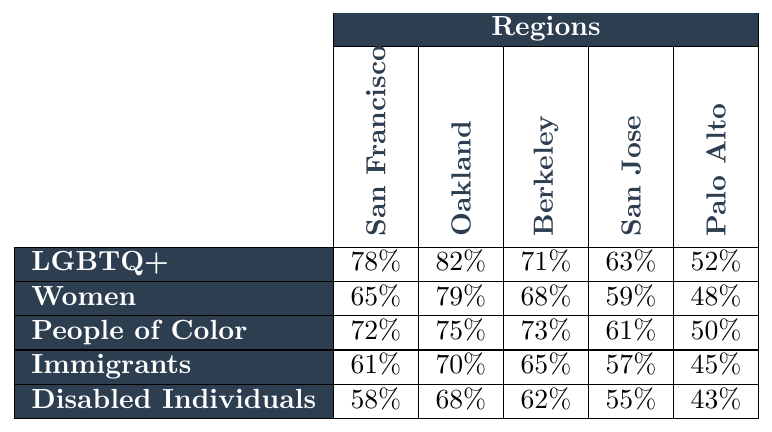What is the attendance rate for women in Oakland? The table shows the attendance rate for women in Oakland is indicated in the intersection of the "Women" row and the "Oakland" column, which is 79%.
Answer: 79% Which community has the lowest attendance rate in Palo Alto? The table shows the attendance rates for each community in Palo Alto. Analyzing the values, Disabled Individuals have the lowest attendance rate at 43%.
Answer: Disabled Individuals What is the average attendance rate for LGBTQ+ individuals across all regions? To find the average, I sum the attendance rates for LGBTQ+ individuals: (78 + 82 + 71 + 63 + 52) = 346. Then, I divide by the number of regions, which is 5, so 346 / 5 = 69.2%.
Answer: 69.2% Is the attendance rate for immigrants in San Jose higher than that for disabled individuals in San Francisco? The attendance rate for immigrants in San Jose is 57%, while the attendance rate for disabled individuals in San Francisco is 58%. Since 57% is less than 58%, the answer is no.
Answer: No Which group shows the highest attendance rate overall? I need to look at all the highest values in each row and then compare them. LGBTQ+ individuals have the highest attendance in Oakland at 82%.
Answer: LGBTQ+ (Oakland) What is the difference in attendance rates between women in San Francisco and women in San Jose? The attendance rate for women in San Francisco is 65% and for women in San Jose is 59%. To find the difference, I subtract: 65 - 59 = 6%.
Answer: 6% What percentage of individuals in Berkeley attended self-defense classes for People of Color? The table shows that the attendance rate for People of Color in Berkeley is 73%.
Answer: 73% Which community has an attendance rate of over 60% in San Jose? In San Jose, looking at the values, the communities with over 60% attendance are LGBTQ+ (63%), People of Color (61%), and Immigrants (57%). However, Immigrants are not over 60%. Thus, LGBTQ+ and People of Color are the valid communities.
Answer: LGBTQ+, People of Color What is the median attendance rate for disabled individuals across all regions? The attendance rates for disabled individuals are: 58%, 68%, 62%, 55%, and 43%. Sorting these gives: 43%, 55%, 58%, 62%, 68%. The median, which is the middle value in this ordered list, is 58%.
Answer: 58% How does the attendance rate for women in San Francisco compare to that of immigrants in the same region? The attendance rate for women in San Francisco is 65%, whereas for immigrants, it is 61%. Since 65% is higher than 61%, we conclude that the attendance rate for women is significantly higher.
Answer: Women are higher 